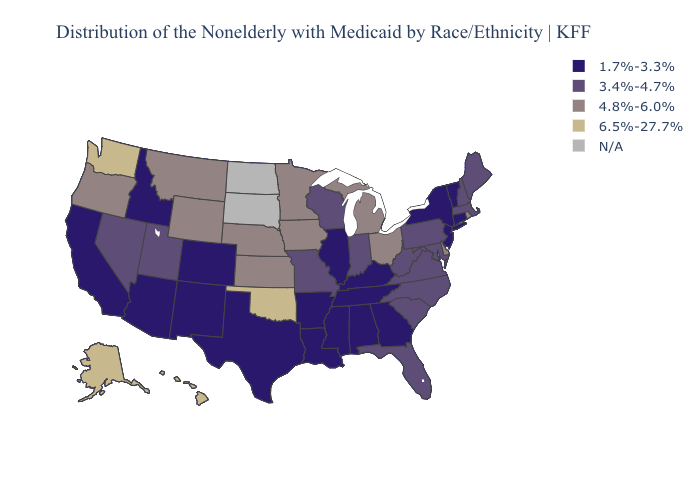Among the states that border Kentucky , does Missouri have the lowest value?
Be succinct. No. Name the states that have a value in the range 4.8%-6.0%?
Answer briefly. Delaware, Iowa, Kansas, Michigan, Minnesota, Montana, Nebraska, Ohio, Oregon, Rhode Island, Wyoming. Does Alabama have the lowest value in the USA?
Keep it brief. Yes. What is the highest value in the Northeast ?
Quick response, please. 4.8%-6.0%. What is the lowest value in states that border Ohio?
Be succinct. 1.7%-3.3%. What is the value of Wyoming?
Quick response, please. 4.8%-6.0%. Name the states that have a value in the range N/A?
Be succinct. North Dakota, South Dakota. What is the lowest value in the USA?
Quick response, please. 1.7%-3.3%. Name the states that have a value in the range 6.5%-27.7%?
Short answer required. Alaska, Hawaii, Oklahoma, Washington. What is the value of North Carolina?
Be succinct. 3.4%-4.7%. Does Tennessee have the lowest value in the USA?
Give a very brief answer. Yes. What is the value of Wyoming?
Give a very brief answer. 4.8%-6.0%. Which states hav the highest value in the MidWest?
Keep it brief. Iowa, Kansas, Michigan, Minnesota, Nebraska, Ohio. Does the first symbol in the legend represent the smallest category?
Short answer required. Yes. Name the states that have a value in the range 1.7%-3.3%?
Quick response, please. Alabama, Arizona, Arkansas, California, Colorado, Connecticut, Georgia, Idaho, Illinois, Kentucky, Louisiana, Mississippi, New Jersey, New Mexico, New York, Tennessee, Texas, Vermont. 